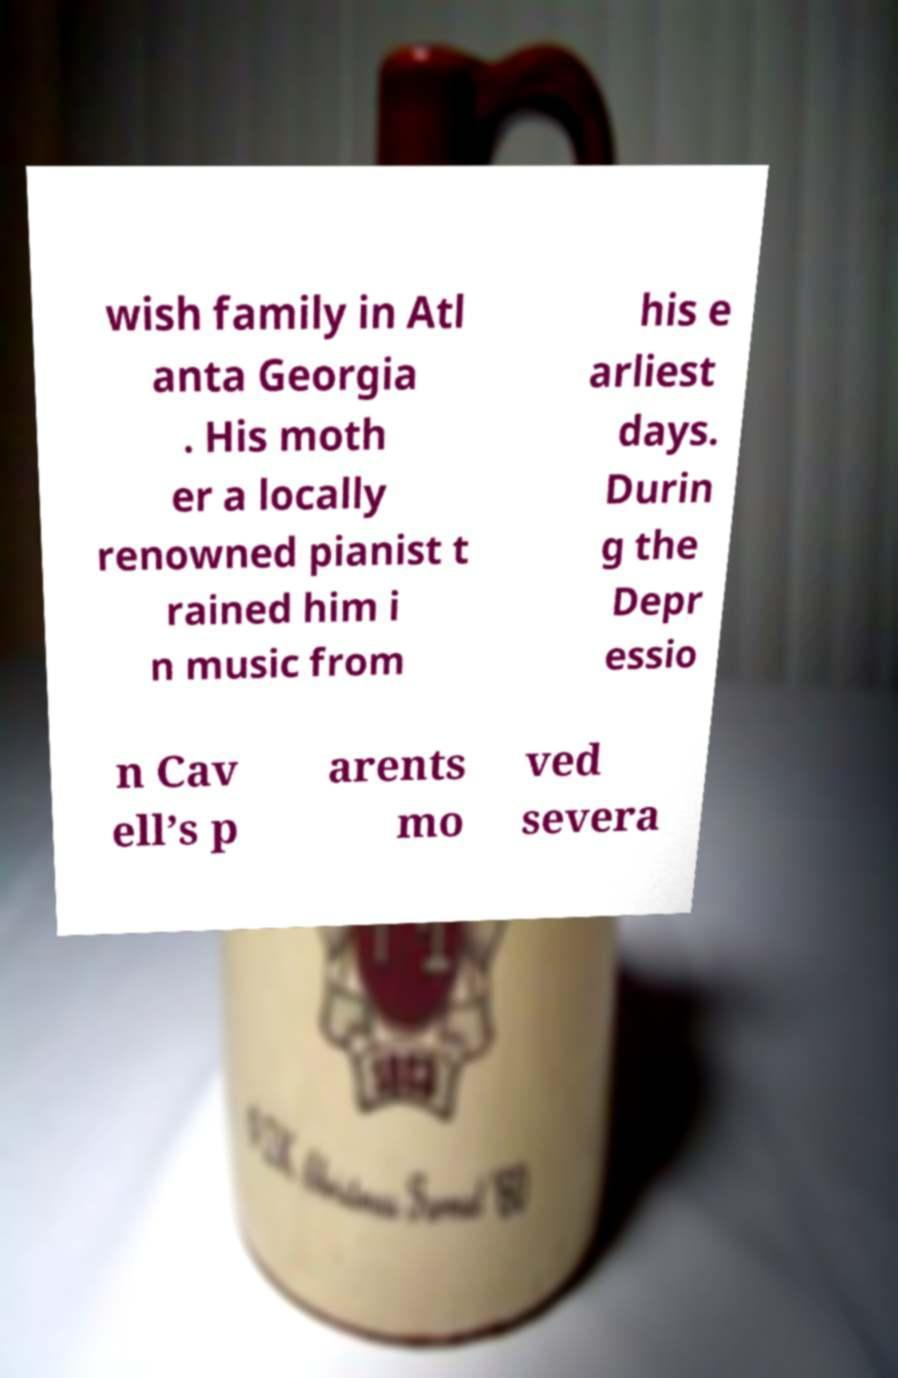What messages or text are displayed in this image? I need them in a readable, typed format. wish family in Atl anta Georgia . His moth er a locally renowned pianist t rained him i n music from his e arliest days. Durin g the Depr essio n Cav ell’s p arents mo ved severa 